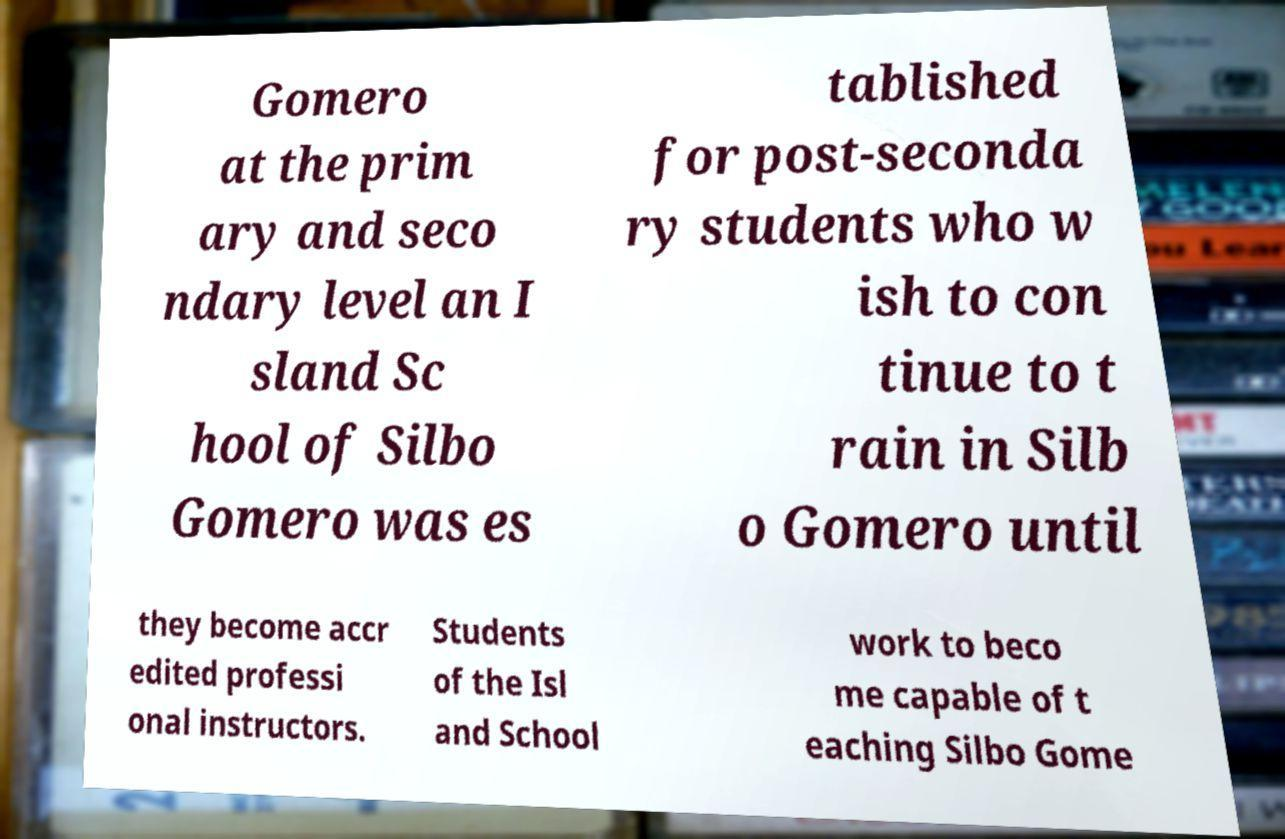There's text embedded in this image that I need extracted. Can you transcribe it verbatim? Gomero at the prim ary and seco ndary level an I sland Sc hool of Silbo Gomero was es tablished for post-seconda ry students who w ish to con tinue to t rain in Silb o Gomero until they become accr edited professi onal instructors. Students of the Isl and School work to beco me capable of t eaching Silbo Gome 